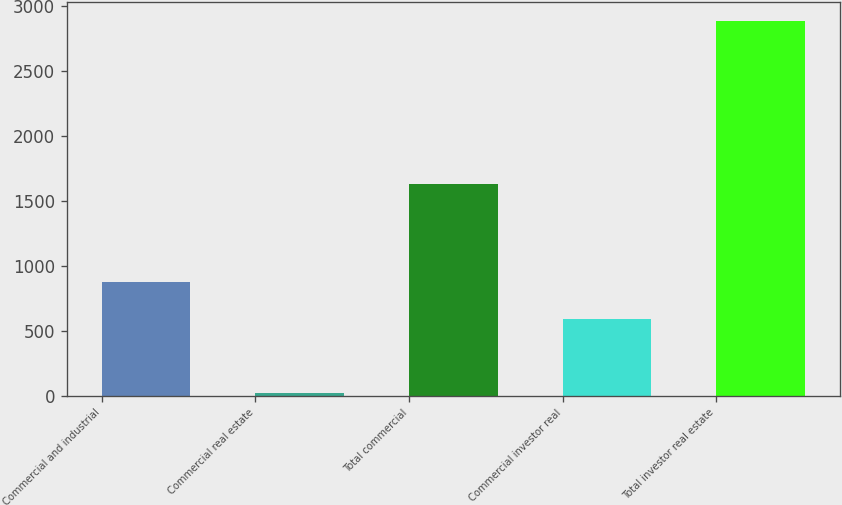<chart> <loc_0><loc_0><loc_500><loc_500><bar_chart><fcel>Commercial and industrial<fcel>Commercial real estate<fcel>Total commercial<fcel>Commercial investor real<fcel>Total investor real estate<nl><fcel>875.7<fcel>23<fcel>1628<fcel>589<fcel>2890<nl></chart> 